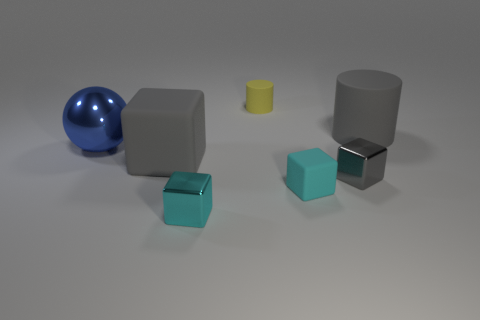Subtract all gray blocks. How many were subtracted if there are1gray blocks left? 1 Subtract all big matte blocks. How many blocks are left? 3 Subtract 0 red cubes. How many objects are left? 7 Subtract all cylinders. How many objects are left? 5 Subtract 3 cubes. How many cubes are left? 1 Subtract all purple cylinders. Subtract all blue blocks. How many cylinders are left? 2 Subtract all gray cubes. How many yellow cylinders are left? 1 Subtract all cyan blocks. Subtract all cyan metal blocks. How many objects are left? 4 Add 2 large gray cylinders. How many large gray cylinders are left? 3 Add 3 small cyan shiny objects. How many small cyan shiny objects exist? 4 